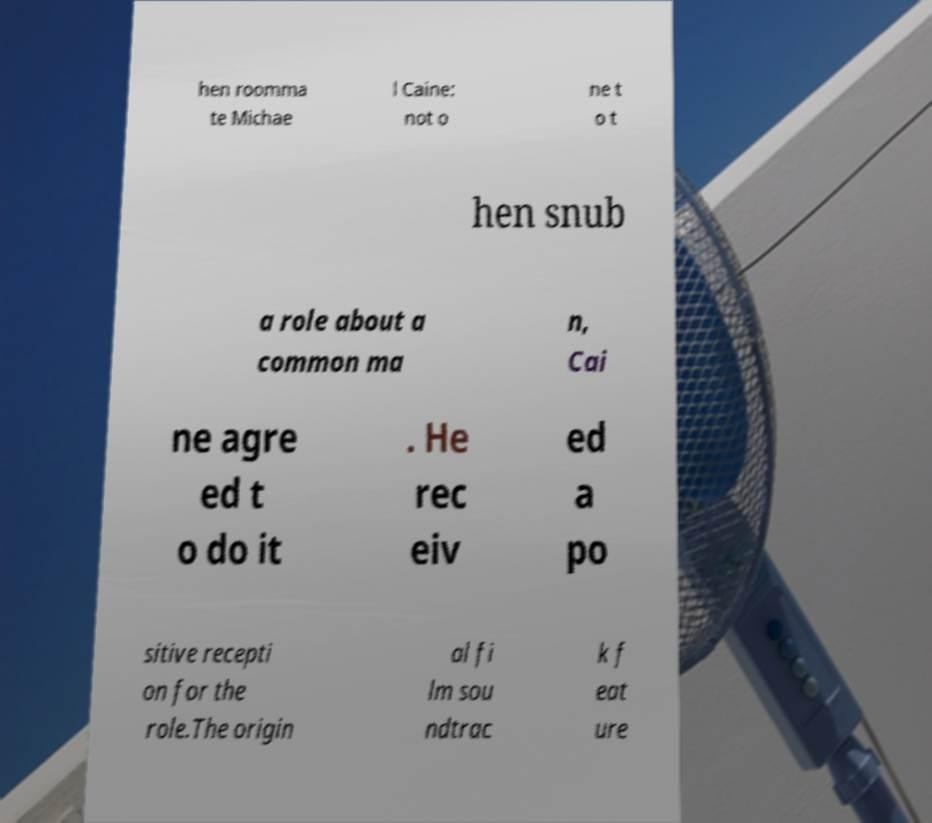I need the written content from this picture converted into text. Can you do that? hen roomma te Michae l Caine: not o ne t o t hen snub a role about a common ma n, Cai ne agre ed t o do it . He rec eiv ed a po sitive recepti on for the role.The origin al fi lm sou ndtrac k f eat ure 